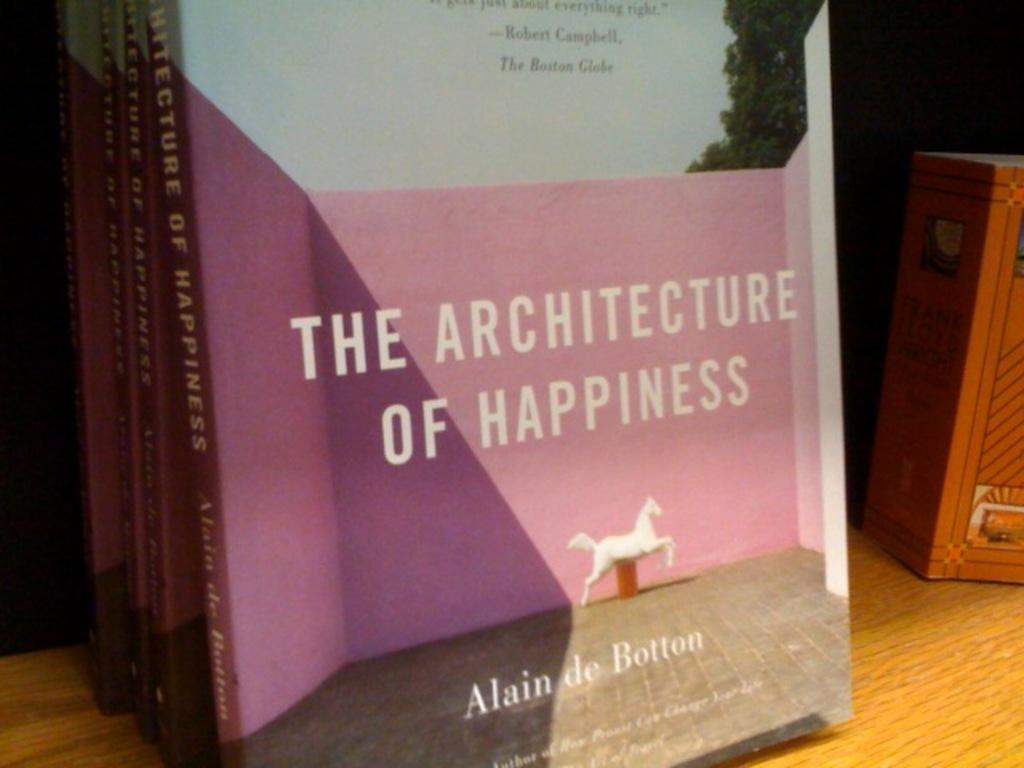<image>
Provide a brief description of the given image. A stack of Alain De Botton novels are on display at a book store. 